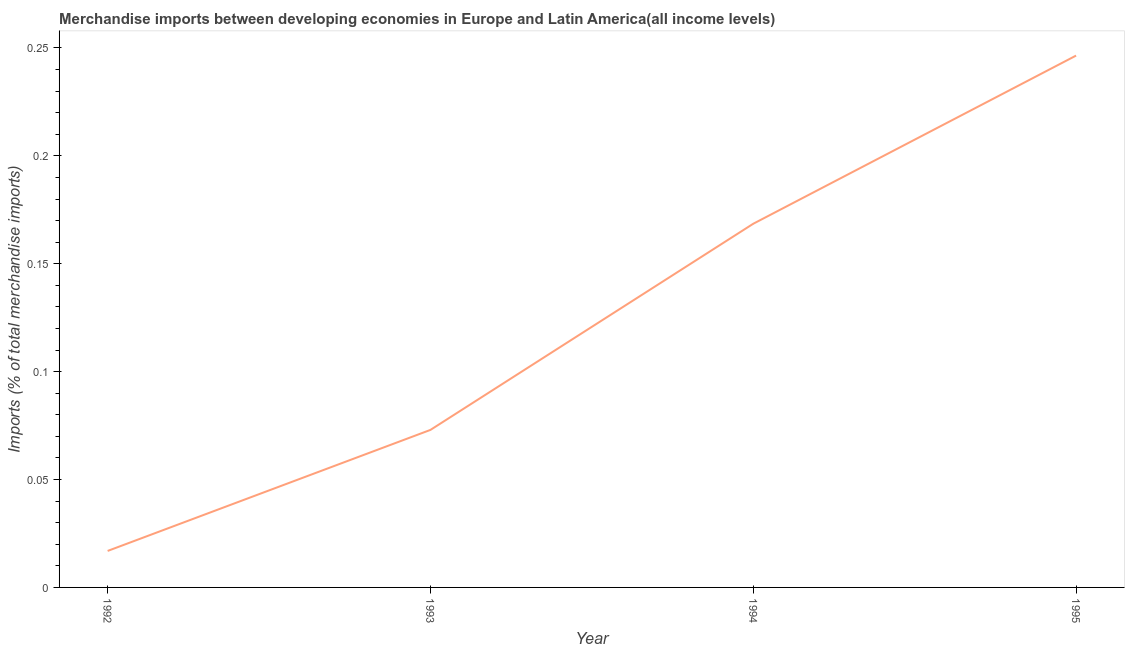What is the merchandise imports in 1994?
Your answer should be compact. 0.17. Across all years, what is the maximum merchandise imports?
Provide a succinct answer. 0.25. Across all years, what is the minimum merchandise imports?
Give a very brief answer. 0.02. What is the sum of the merchandise imports?
Offer a terse response. 0.5. What is the difference between the merchandise imports in 1993 and 1995?
Provide a short and direct response. -0.17. What is the average merchandise imports per year?
Provide a short and direct response. 0.13. What is the median merchandise imports?
Make the answer very short. 0.12. In how many years, is the merchandise imports greater than 0.23 %?
Your response must be concise. 1. Do a majority of the years between 1994 and 1992 (inclusive) have merchandise imports greater than 0.22 %?
Your answer should be very brief. No. What is the ratio of the merchandise imports in 1992 to that in 1995?
Give a very brief answer. 0.07. Is the difference between the merchandise imports in 1993 and 1994 greater than the difference between any two years?
Make the answer very short. No. What is the difference between the highest and the second highest merchandise imports?
Offer a very short reply. 0.08. What is the difference between the highest and the lowest merchandise imports?
Provide a short and direct response. 0.23. How many lines are there?
Offer a very short reply. 1. What is the difference between two consecutive major ticks on the Y-axis?
Your response must be concise. 0.05. Does the graph contain grids?
Your answer should be compact. No. What is the title of the graph?
Make the answer very short. Merchandise imports between developing economies in Europe and Latin America(all income levels). What is the label or title of the X-axis?
Your response must be concise. Year. What is the label or title of the Y-axis?
Ensure brevity in your answer.  Imports (% of total merchandise imports). What is the Imports (% of total merchandise imports) in 1992?
Provide a succinct answer. 0.02. What is the Imports (% of total merchandise imports) in 1993?
Offer a very short reply. 0.07. What is the Imports (% of total merchandise imports) in 1994?
Ensure brevity in your answer.  0.17. What is the Imports (% of total merchandise imports) in 1995?
Offer a very short reply. 0.25. What is the difference between the Imports (% of total merchandise imports) in 1992 and 1993?
Offer a very short reply. -0.06. What is the difference between the Imports (% of total merchandise imports) in 1992 and 1994?
Make the answer very short. -0.15. What is the difference between the Imports (% of total merchandise imports) in 1992 and 1995?
Make the answer very short. -0.23. What is the difference between the Imports (% of total merchandise imports) in 1993 and 1994?
Ensure brevity in your answer.  -0.1. What is the difference between the Imports (% of total merchandise imports) in 1993 and 1995?
Your answer should be very brief. -0.17. What is the difference between the Imports (% of total merchandise imports) in 1994 and 1995?
Give a very brief answer. -0.08. What is the ratio of the Imports (% of total merchandise imports) in 1992 to that in 1993?
Your answer should be compact. 0.23. What is the ratio of the Imports (% of total merchandise imports) in 1992 to that in 1994?
Your answer should be very brief. 0.1. What is the ratio of the Imports (% of total merchandise imports) in 1992 to that in 1995?
Give a very brief answer. 0.07. What is the ratio of the Imports (% of total merchandise imports) in 1993 to that in 1994?
Keep it short and to the point. 0.43. What is the ratio of the Imports (% of total merchandise imports) in 1993 to that in 1995?
Make the answer very short. 0.3. What is the ratio of the Imports (% of total merchandise imports) in 1994 to that in 1995?
Your response must be concise. 0.68. 